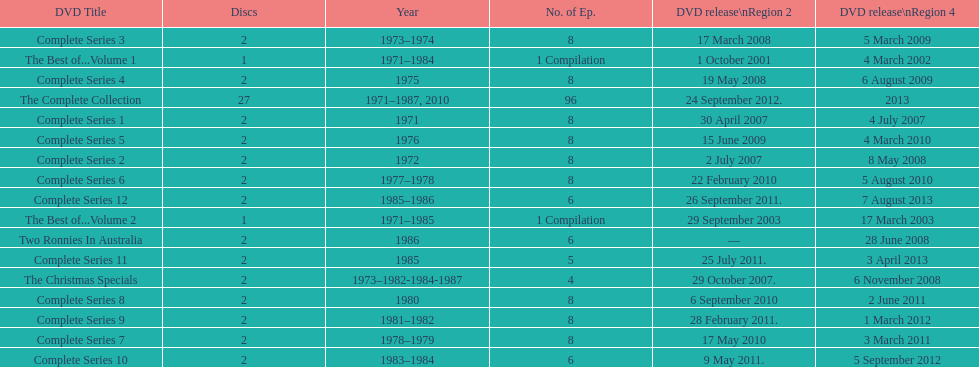The television show "the two ronnies" ran for a total of how many seasons? 12. 